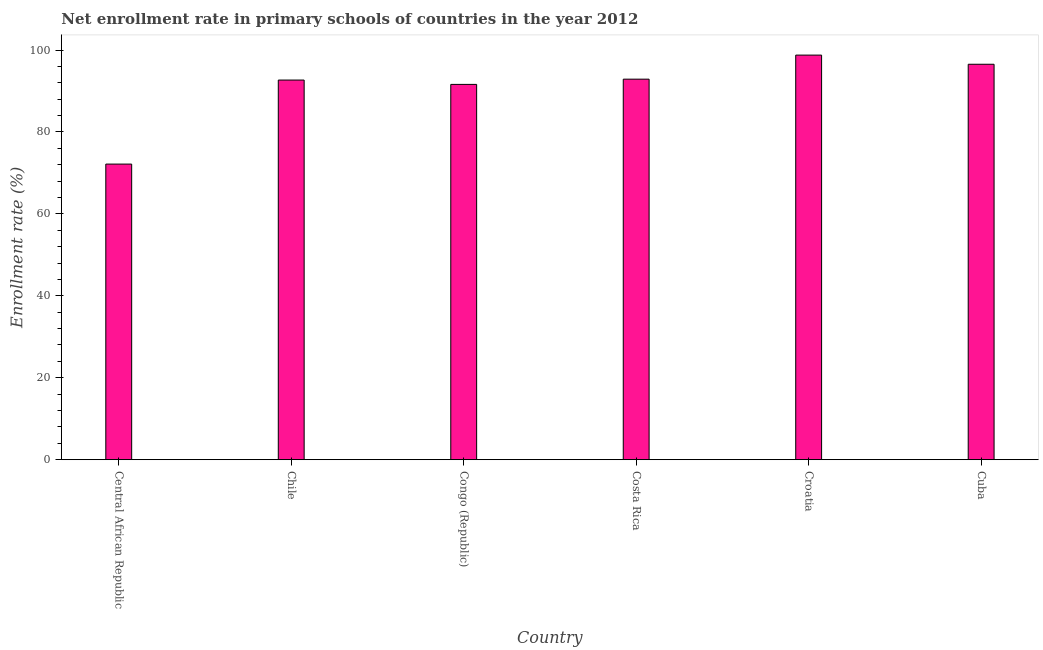Does the graph contain any zero values?
Provide a short and direct response. No. Does the graph contain grids?
Your response must be concise. No. What is the title of the graph?
Your response must be concise. Net enrollment rate in primary schools of countries in the year 2012. What is the label or title of the Y-axis?
Your answer should be very brief. Enrollment rate (%). What is the net enrollment rate in primary schools in Cuba?
Your answer should be very brief. 96.53. Across all countries, what is the maximum net enrollment rate in primary schools?
Give a very brief answer. 98.77. Across all countries, what is the minimum net enrollment rate in primary schools?
Keep it short and to the point. 72.16. In which country was the net enrollment rate in primary schools maximum?
Your response must be concise. Croatia. In which country was the net enrollment rate in primary schools minimum?
Offer a very short reply. Central African Republic. What is the sum of the net enrollment rate in primary schools?
Offer a terse response. 544.66. What is the difference between the net enrollment rate in primary schools in Costa Rica and Croatia?
Keep it short and to the point. -5.87. What is the average net enrollment rate in primary schools per country?
Provide a short and direct response. 90.78. What is the median net enrollment rate in primary schools?
Your answer should be very brief. 92.79. Is the difference between the net enrollment rate in primary schools in Costa Rica and Cuba greater than the difference between any two countries?
Make the answer very short. No. What is the difference between the highest and the second highest net enrollment rate in primary schools?
Make the answer very short. 2.23. What is the difference between the highest and the lowest net enrollment rate in primary schools?
Provide a short and direct response. 26.6. In how many countries, is the net enrollment rate in primary schools greater than the average net enrollment rate in primary schools taken over all countries?
Offer a terse response. 5. How many bars are there?
Make the answer very short. 6. Are all the bars in the graph horizontal?
Offer a very short reply. No. How many countries are there in the graph?
Ensure brevity in your answer.  6. What is the Enrollment rate (%) in Central African Republic?
Your answer should be very brief. 72.16. What is the Enrollment rate (%) of Chile?
Provide a short and direct response. 92.68. What is the Enrollment rate (%) of Congo (Republic)?
Provide a succinct answer. 91.62. What is the Enrollment rate (%) in Costa Rica?
Offer a terse response. 92.89. What is the Enrollment rate (%) in Croatia?
Make the answer very short. 98.77. What is the Enrollment rate (%) in Cuba?
Your answer should be very brief. 96.53. What is the difference between the Enrollment rate (%) in Central African Republic and Chile?
Your answer should be very brief. -20.52. What is the difference between the Enrollment rate (%) in Central African Republic and Congo (Republic)?
Give a very brief answer. -19.45. What is the difference between the Enrollment rate (%) in Central African Republic and Costa Rica?
Your answer should be very brief. -20.73. What is the difference between the Enrollment rate (%) in Central African Republic and Croatia?
Your answer should be compact. -26.6. What is the difference between the Enrollment rate (%) in Central African Republic and Cuba?
Your response must be concise. -24.37. What is the difference between the Enrollment rate (%) in Chile and Congo (Republic)?
Your response must be concise. 1.06. What is the difference between the Enrollment rate (%) in Chile and Costa Rica?
Give a very brief answer. -0.22. What is the difference between the Enrollment rate (%) in Chile and Croatia?
Offer a terse response. -6.09. What is the difference between the Enrollment rate (%) in Chile and Cuba?
Your answer should be very brief. -3.85. What is the difference between the Enrollment rate (%) in Congo (Republic) and Costa Rica?
Keep it short and to the point. -1.28. What is the difference between the Enrollment rate (%) in Congo (Republic) and Croatia?
Your response must be concise. -7.15. What is the difference between the Enrollment rate (%) in Congo (Republic) and Cuba?
Make the answer very short. -4.92. What is the difference between the Enrollment rate (%) in Costa Rica and Croatia?
Provide a short and direct response. -5.87. What is the difference between the Enrollment rate (%) in Costa Rica and Cuba?
Give a very brief answer. -3.64. What is the difference between the Enrollment rate (%) in Croatia and Cuba?
Make the answer very short. 2.23. What is the ratio of the Enrollment rate (%) in Central African Republic to that in Chile?
Your answer should be very brief. 0.78. What is the ratio of the Enrollment rate (%) in Central African Republic to that in Congo (Republic)?
Provide a succinct answer. 0.79. What is the ratio of the Enrollment rate (%) in Central African Republic to that in Costa Rica?
Make the answer very short. 0.78. What is the ratio of the Enrollment rate (%) in Central African Republic to that in Croatia?
Offer a terse response. 0.73. What is the ratio of the Enrollment rate (%) in Central African Republic to that in Cuba?
Give a very brief answer. 0.75. What is the ratio of the Enrollment rate (%) in Chile to that in Costa Rica?
Offer a terse response. 1. What is the ratio of the Enrollment rate (%) in Chile to that in Croatia?
Give a very brief answer. 0.94. What is the ratio of the Enrollment rate (%) in Chile to that in Cuba?
Your answer should be very brief. 0.96. What is the ratio of the Enrollment rate (%) in Congo (Republic) to that in Costa Rica?
Your answer should be very brief. 0.99. What is the ratio of the Enrollment rate (%) in Congo (Republic) to that in Croatia?
Provide a short and direct response. 0.93. What is the ratio of the Enrollment rate (%) in Congo (Republic) to that in Cuba?
Give a very brief answer. 0.95. What is the ratio of the Enrollment rate (%) in Costa Rica to that in Croatia?
Ensure brevity in your answer.  0.94. What is the ratio of the Enrollment rate (%) in Costa Rica to that in Cuba?
Your answer should be very brief. 0.96. What is the ratio of the Enrollment rate (%) in Croatia to that in Cuba?
Provide a succinct answer. 1.02. 